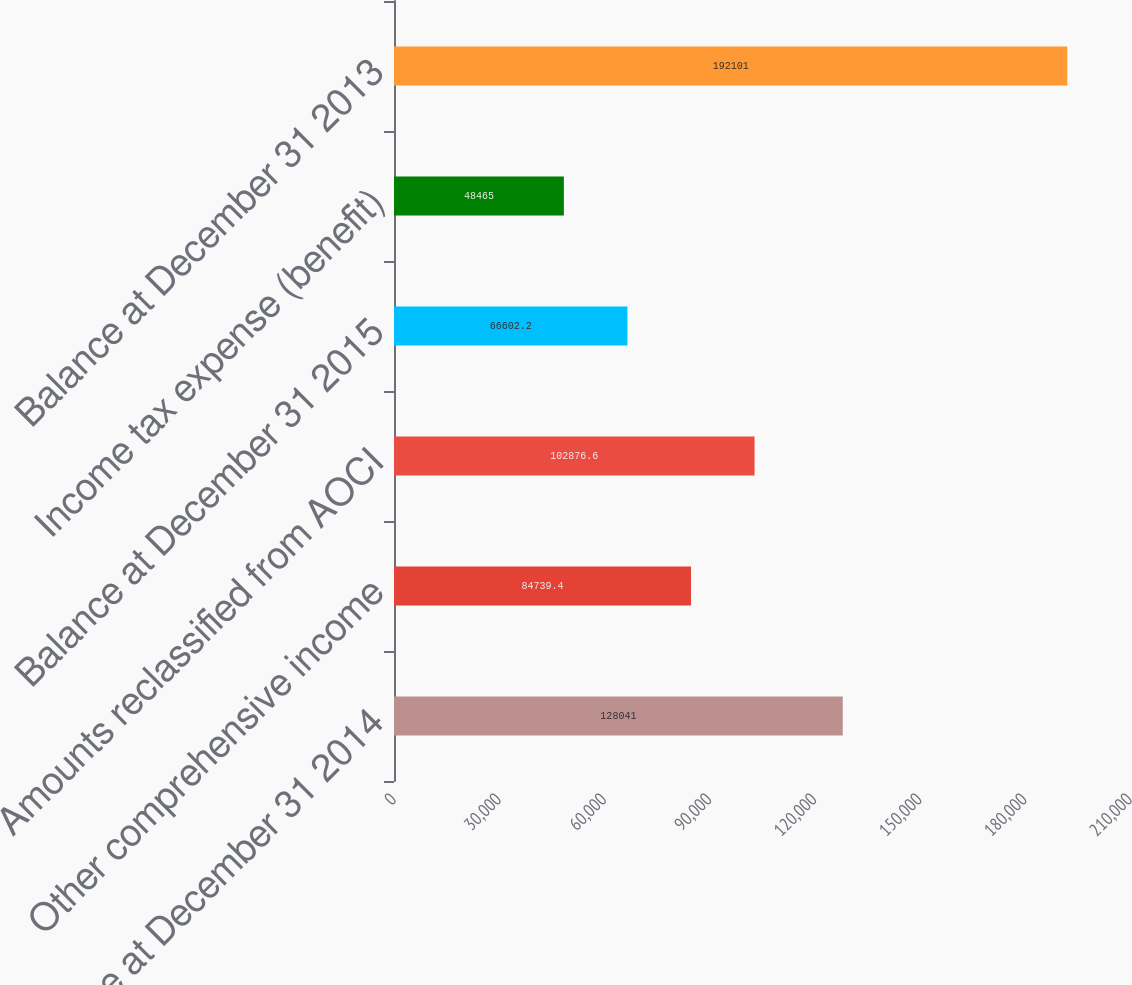Convert chart to OTSL. <chart><loc_0><loc_0><loc_500><loc_500><bar_chart><fcel>Balance at December 31 2014<fcel>Other comprehensive income<fcel>Amounts reclassified from AOCI<fcel>Balance at December 31 2015<fcel>Income tax expense (benefit)<fcel>Balance at December 31 2013<nl><fcel>128041<fcel>84739.4<fcel>102877<fcel>66602.2<fcel>48465<fcel>192101<nl></chart> 